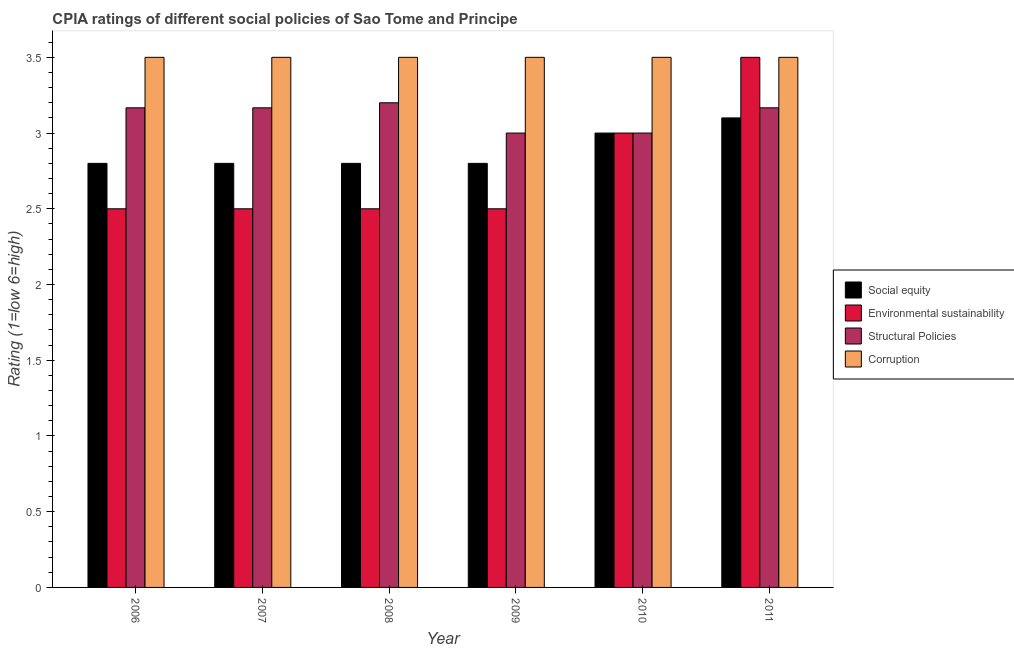How many different coloured bars are there?
Offer a very short reply. 4. How many groups of bars are there?
Your response must be concise. 6. Are the number of bars per tick equal to the number of legend labels?
Offer a very short reply. Yes. How many bars are there on the 3rd tick from the right?
Your answer should be compact. 4. What is the label of the 6th group of bars from the left?
Your answer should be very brief. 2011. What is the cpia rating of structural policies in 2006?
Your answer should be compact. 3.17. In which year was the cpia rating of corruption minimum?
Ensure brevity in your answer.  2006. What is the total cpia rating of environmental sustainability in the graph?
Provide a succinct answer. 16.5. What is the difference between the cpia rating of structural policies in 2010 and that in 2011?
Ensure brevity in your answer.  -0.17. What is the difference between the cpia rating of social equity in 2010 and the cpia rating of structural policies in 2007?
Keep it short and to the point. 0.2. What is the average cpia rating of social equity per year?
Your response must be concise. 2.88. In the year 2009, what is the difference between the cpia rating of corruption and cpia rating of structural policies?
Ensure brevity in your answer.  0. In how many years, is the cpia rating of social equity greater than 2.3?
Ensure brevity in your answer.  6. What is the ratio of the cpia rating of structural policies in 2006 to that in 2010?
Ensure brevity in your answer.  1.06. Is the cpia rating of environmental sustainability in 2008 less than that in 2011?
Your response must be concise. Yes. What is the difference between the highest and the second highest cpia rating of corruption?
Your response must be concise. 0. What is the difference between the highest and the lowest cpia rating of structural policies?
Give a very brief answer. 0.2. Is it the case that in every year, the sum of the cpia rating of environmental sustainability and cpia rating of social equity is greater than the sum of cpia rating of structural policies and cpia rating of corruption?
Provide a short and direct response. No. What does the 4th bar from the left in 2007 represents?
Make the answer very short. Corruption. What does the 4th bar from the right in 2007 represents?
Keep it short and to the point. Social equity. How many bars are there?
Provide a short and direct response. 24. Are all the bars in the graph horizontal?
Offer a very short reply. No. How many years are there in the graph?
Give a very brief answer. 6. What is the difference between two consecutive major ticks on the Y-axis?
Keep it short and to the point. 0.5. Does the graph contain any zero values?
Ensure brevity in your answer.  No. How are the legend labels stacked?
Offer a terse response. Vertical. What is the title of the graph?
Provide a succinct answer. CPIA ratings of different social policies of Sao Tome and Principe. Does "Italy" appear as one of the legend labels in the graph?
Give a very brief answer. No. What is the label or title of the X-axis?
Offer a very short reply. Year. What is the Rating (1=low 6=high) of Structural Policies in 2006?
Ensure brevity in your answer.  3.17. What is the Rating (1=low 6=high) of Social equity in 2007?
Make the answer very short. 2.8. What is the Rating (1=low 6=high) of Environmental sustainability in 2007?
Your response must be concise. 2.5. What is the Rating (1=low 6=high) of Structural Policies in 2007?
Keep it short and to the point. 3.17. What is the Rating (1=low 6=high) in Social equity in 2008?
Make the answer very short. 2.8. What is the Rating (1=low 6=high) of Environmental sustainability in 2008?
Offer a very short reply. 2.5. What is the Rating (1=low 6=high) in Corruption in 2008?
Keep it short and to the point. 3.5. What is the Rating (1=low 6=high) in Social equity in 2009?
Offer a very short reply. 2.8. What is the Rating (1=low 6=high) in Social equity in 2010?
Offer a very short reply. 3. What is the Rating (1=low 6=high) in Environmental sustainability in 2010?
Ensure brevity in your answer.  3. What is the Rating (1=low 6=high) of Structural Policies in 2010?
Give a very brief answer. 3. What is the Rating (1=low 6=high) in Corruption in 2010?
Provide a succinct answer. 3.5. What is the Rating (1=low 6=high) of Structural Policies in 2011?
Offer a terse response. 3.17. Across all years, what is the maximum Rating (1=low 6=high) in Social equity?
Your response must be concise. 3.1. Across all years, what is the maximum Rating (1=low 6=high) in Environmental sustainability?
Give a very brief answer. 3.5. Across all years, what is the maximum Rating (1=low 6=high) in Structural Policies?
Your response must be concise. 3.2. Across all years, what is the minimum Rating (1=low 6=high) in Social equity?
Your answer should be very brief. 2.8. What is the total Rating (1=low 6=high) of Environmental sustainability in the graph?
Give a very brief answer. 16.5. What is the total Rating (1=low 6=high) of Structural Policies in the graph?
Your answer should be very brief. 18.7. What is the difference between the Rating (1=low 6=high) in Environmental sustainability in 2006 and that in 2007?
Keep it short and to the point. 0. What is the difference between the Rating (1=low 6=high) in Structural Policies in 2006 and that in 2007?
Your answer should be very brief. 0. What is the difference between the Rating (1=low 6=high) of Corruption in 2006 and that in 2007?
Your answer should be very brief. 0. What is the difference between the Rating (1=low 6=high) in Social equity in 2006 and that in 2008?
Your answer should be very brief. 0. What is the difference between the Rating (1=low 6=high) in Environmental sustainability in 2006 and that in 2008?
Your answer should be compact. 0. What is the difference between the Rating (1=low 6=high) in Structural Policies in 2006 and that in 2008?
Your answer should be compact. -0.03. What is the difference between the Rating (1=low 6=high) in Environmental sustainability in 2006 and that in 2009?
Your answer should be very brief. 0. What is the difference between the Rating (1=low 6=high) of Structural Policies in 2006 and that in 2009?
Offer a very short reply. 0.17. What is the difference between the Rating (1=low 6=high) of Corruption in 2006 and that in 2009?
Provide a succinct answer. 0. What is the difference between the Rating (1=low 6=high) in Corruption in 2006 and that in 2010?
Provide a succinct answer. 0. What is the difference between the Rating (1=low 6=high) of Environmental sustainability in 2006 and that in 2011?
Give a very brief answer. -1. What is the difference between the Rating (1=low 6=high) of Corruption in 2006 and that in 2011?
Give a very brief answer. 0. What is the difference between the Rating (1=low 6=high) of Environmental sustainability in 2007 and that in 2008?
Ensure brevity in your answer.  0. What is the difference between the Rating (1=low 6=high) in Structural Policies in 2007 and that in 2008?
Give a very brief answer. -0.03. What is the difference between the Rating (1=low 6=high) in Environmental sustainability in 2007 and that in 2009?
Keep it short and to the point. 0. What is the difference between the Rating (1=low 6=high) in Structural Policies in 2007 and that in 2009?
Keep it short and to the point. 0.17. What is the difference between the Rating (1=low 6=high) of Corruption in 2007 and that in 2009?
Make the answer very short. 0. What is the difference between the Rating (1=low 6=high) of Corruption in 2007 and that in 2010?
Give a very brief answer. 0. What is the difference between the Rating (1=low 6=high) of Structural Policies in 2007 and that in 2011?
Make the answer very short. 0. What is the difference between the Rating (1=low 6=high) of Corruption in 2007 and that in 2011?
Provide a short and direct response. 0. What is the difference between the Rating (1=low 6=high) in Social equity in 2008 and that in 2009?
Offer a very short reply. 0. What is the difference between the Rating (1=low 6=high) of Structural Policies in 2008 and that in 2009?
Provide a succinct answer. 0.2. What is the difference between the Rating (1=low 6=high) of Social equity in 2008 and that in 2010?
Give a very brief answer. -0.2. What is the difference between the Rating (1=low 6=high) in Environmental sustainability in 2008 and that in 2010?
Keep it short and to the point. -0.5. What is the difference between the Rating (1=low 6=high) in Structural Policies in 2008 and that in 2010?
Your answer should be very brief. 0.2. What is the difference between the Rating (1=low 6=high) in Corruption in 2008 and that in 2010?
Make the answer very short. 0. What is the difference between the Rating (1=low 6=high) of Social equity in 2008 and that in 2011?
Offer a very short reply. -0.3. What is the difference between the Rating (1=low 6=high) of Structural Policies in 2008 and that in 2011?
Your answer should be very brief. 0.03. What is the difference between the Rating (1=low 6=high) of Environmental sustainability in 2009 and that in 2010?
Your answer should be very brief. -0.5. What is the difference between the Rating (1=low 6=high) of Structural Policies in 2009 and that in 2010?
Offer a very short reply. 0. What is the difference between the Rating (1=low 6=high) of Structural Policies in 2009 and that in 2011?
Make the answer very short. -0.17. What is the difference between the Rating (1=low 6=high) in Corruption in 2009 and that in 2011?
Keep it short and to the point. 0. What is the difference between the Rating (1=low 6=high) in Social equity in 2010 and that in 2011?
Offer a terse response. -0.1. What is the difference between the Rating (1=low 6=high) of Social equity in 2006 and the Rating (1=low 6=high) of Structural Policies in 2007?
Ensure brevity in your answer.  -0.37. What is the difference between the Rating (1=low 6=high) in Environmental sustainability in 2006 and the Rating (1=low 6=high) in Structural Policies in 2007?
Give a very brief answer. -0.67. What is the difference between the Rating (1=low 6=high) in Environmental sustainability in 2006 and the Rating (1=low 6=high) in Corruption in 2007?
Offer a terse response. -1. What is the difference between the Rating (1=low 6=high) of Structural Policies in 2006 and the Rating (1=low 6=high) of Corruption in 2007?
Keep it short and to the point. -0.33. What is the difference between the Rating (1=low 6=high) of Social equity in 2006 and the Rating (1=low 6=high) of Structural Policies in 2008?
Give a very brief answer. -0.4. What is the difference between the Rating (1=low 6=high) of Environmental sustainability in 2006 and the Rating (1=low 6=high) of Structural Policies in 2008?
Offer a very short reply. -0.7. What is the difference between the Rating (1=low 6=high) of Social equity in 2006 and the Rating (1=low 6=high) of Environmental sustainability in 2009?
Offer a very short reply. 0.3. What is the difference between the Rating (1=low 6=high) of Social equity in 2006 and the Rating (1=low 6=high) of Corruption in 2009?
Your answer should be very brief. -0.7. What is the difference between the Rating (1=low 6=high) in Environmental sustainability in 2006 and the Rating (1=low 6=high) in Corruption in 2009?
Provide a succinct answer. -1. What is the difference between the Rating (1=low 6=high) of Structural Policies in 2006 and the Rating (1=low 6=high) of Corruption in 2009?
Keep it short and to the point. -0.33. What is the difference between the Rating (1=low 6=high) of Social equity in 2006 and the Rating (1=low 6=high) of Environmental sustainability in 2010?
Give a very brief answer. -0.2. What is the difference between the Rating (1=low 6=high) in Social equity in 2006 and the Rating (1=low 6=high) in Structural Policies in 2010?
Your answer should be very brief. -0.2. What is the difference between the Rating (1=low 6=high) in Environmental sustainability in 2006 and the Rating (1=low 6=high) in Structural Policies in 2010?
Make the answer very short. -0.5. What is the difference between the Rating (1=low 6=high) in Environmental sustainability in 2006 and the Rating (1=low 6=high) in Corruption in 2010?
Keep it short and to the point. -1. What is the difference between the Rating (1=low 6=high) in Structural Policies in 2006 and the Rating (1=low 6=high) in Corruption in 2010?
Make the answer very short. -0.33. What is the difference between the Rating (1=low 6=high) of Social equity in 2006 and the Rating (1=low 6=high) of Structural Policies in 2011?
Ensure brevity in your answer.  -0.37. What is the difference between the Rating (1=low 6=high) of Environmental sustainability in 2006 and the Rating (1=low 6=high) of Structural Policies in 2011?
Make the answer very short. -0.67. What is the difference between the Rating (1=low 6=high) of Environmental sustainability in 2006 and the Rating (1=low 6=high) of Corruption in 2011?
Provide a succinct answer. -1. What is the difference between the Rating (1=low 6=high) of Social equity in 2007 and the Rating (1=low 6=high) of Structural Policies in 2008?
Provide a succinct answer. -0.4. What is the difference between the Rating (1=low 6=high) in Environmental sustainability in 2007 and the Rating (1=low 6=high) in Structural Policies in 2008?
Make the answer very short. -0.7. What is the difference between the Rating (1=low 6=high) of Environmental sustainability in 2007 and the Rating (1=low 6=high) of Corruption in 2008?
Give a very brief answer. -1. What is the difference between the Rating (1=low 6=high) in Structural Policies in 2007 and the Rating (1=low 6=high) in Corruption in 2008?
Offer a terse response. -0.33. What is the difference between the Rating (1=low 6=high) in Social equity in 2007 and the Rating (1=low 6=high) in Environmental sustainability in 2009?
Your answer should be very brief. 0.3. What is the difference between the Rating (1=low 6=high) of Social equity in 2007 and the Rating (1=low 6=high) of Structural Policies in 2009?
Give a very brief answer. -0.2. What is the difference between the Rating (1=low 6=high) in Social equity in 2007 and the Rating (1=low 6=high) in Corruption in 2009?
Make the answer very short. -0.7. What is the difference between the Rating (1=low 6=high) of Environmental sustainability in 2007 and the Rating (1=low 6=high) of Structural Policies in 2009?
Make the answer very short. -0.5. What is the difference between the Rating (1=low 6=high) in Environmental sustainability in 2007 and the Rating (1=low 6=high) in Corruption in 2009?
Provide a succinct answer. -1. What is the difference between the Rating (1=low 6=high) in Social equity in 2007 and the Rating (1=low 6=high) in Environmental sustainability in 2010?
Give a very brief answer. -0.2. What is the difference between the Rating (1=low 6=high) in Social equity in 2007 and the Rating (1=low 6=high) in Structural Policies in 2010?
Your answer should be very brief. -0.2. What is the difference between the Rating (1=low 6=high) of Social equity in 2007 and the Rating (1=low 6=high) of Environmental sustainability in 2011?
Provide a succinct answer. -0.7. What is the difference between the Rating (1=low 6=high) in Social equity in 2007 and the Rating (1=low 6=high) in Structural Policies in 2011?
Ensure brevity in your answer.  -0.37. What is the difference between the Rating (1=low 6=high) in Environmental sustainability in 2007 and the Rating (1=low 6=high) in Corruption in 2011?
Make the answer very short. -1. What is the difference between the Rating (1=low 6=high) of Environmental sustainability in 2008 and the Rating (1=low 6=high) of Corruption in 2009?
Offer a very short reply. -1. What is the difference between the Rating (1=low 6=high) in Structural Policies in 2008 and the Rating (1=low 6=high) in Corruption in 2009?
Keep it short and to the point. -0.3. What is the difference between the Rating (1=low 6=high) of Social equity in 2008 and the Rating (1=low 6=high) of Environmental sustainability in 2010?
Offer a very short reply. -0.2. What is the difference between the Rating (1=low 6=high) of Social equity in 2008 and the Rating (1=low 6=high) of Corruption in 2010?
Provide a short and direct response. -0.7. What is the difference between the Rating (1=low 6=high) in Environmental sustainability in 2008 and the Rating (1=low 6=high) in Structural Policies in 2010?
Offer a very short reply. -0.5. What is the difference between the Rating (1=low 6=high) of Environmental sustainability in 2008 and the Rating (1=low 6=high) of Corruption in 2010?
Ensure brevity in your answer.  -1. What is the difference between the Rating (1=low 6=high) in Social equity in 2008 and the Rating (1=low 6=high) in Structural Policies in 2011?
Give a very brief answer. -0.37. What is the difference between the Rating (1=low 6=high) of Social equity in 2008 and the Rating (1=low 6=high) of Corruption in 2011?
Your response must be concise. -0.7. What is the difference between the Rating (1=low 6=high) of Environmental sustainability in 2008 and the Rating (1=low 6=high) of Structural Policies in 2011?
Your response must be concise. -0.67. What is the difference between the Rating (1=low 6=high) in Environmental sustainability in 2008 and the Rating (1=low 6=high) in Corruption in 2011?
Your response must be concise. -1. What is the difference between the Rating (1=low 6=high) of Structural Policies in 2008 and the Rating (1=low 6=high) of Corruption in 2011?
Your answer should be very brief. -0.3. What is the difference between the Rating (1=low 6=high) of Social equity in 2009 and the Rating (1=low 6=high) of Environmental sustainability in 2010?
Keep it short and to the point. -0.2. What is the difference between the Rating (1=low 6=high) of Social equity in 2009 and the Rating (1=low 6=high) of Structural Policies in 2010?
Make the answer very short. -0.2. What is the difference between the Rating (1=low 6=high) in Social equity in 2009 and the Rating (1=low 6=high) in Corruption in 2010?
Provide a succinct answer. -0.7. What is the difference between the Rating (1=low 6=high) of Environmental sustainability in 2009 and the Rating (1=low 6=high) of Structural Policies in 2010?
Your response must be concise. -0.5. What is the difference between the Rating (1=low 6=high) in Social equity in 2009 and the Rating (1=low 6=high) in Environmental sustainability in 2011?
Your answer should be very brief. -0.7. What is the difference between the Rating (1=low 6=high) in Social equity in 2009 and the Rating (1=low 6=high) in Structural Policies in 2011?
Your answer should be compact. -0.37. What is the difference between the Rating (1=low 6=high) in Social equity in 2009 and the Rating (1=low 6=high) in Corruption in 2011?
Provide a short and direct response. -0.7. What is the difference between the Rating (1=low 6=high) of Environmental sustainability in 2009 and the Rating (1=low 6=high) of Structural Policies in 2011?
Offer a very short reply. -0.67. What is the difference between the Rating (1=low 6=high) in Environmental sustainability in 2009 and the Rating (1=low 6=high) in Corruption in 2011?
Offer a very short reply. -1. What is the difference between the Rating (1=low 6=high) of Social equity in 2010 and the Rating (1=low 6=high) of Environmental sustainability in 2011?
Your answer should be very brief. -0.5. What is the difference between the Rating (1=low 6=high) in Social equity in 2010 and the Rating (1=low 6=high) in Structural Policies in 2011?
Ensure brevity in your answer.  -0.17. What is the difference between the Rating (1=low 6=high) in Social equity in 2010 and the Rating (1=low 6=high) in Corruption in 2011?
Your answer should be very brief. -0.5. What is the difference between the Rating (1=low 6=high) of Environmental sustainability in 2010 and the Rating (1=low 6=high) of Structural Policies in 2011?
Your answer should be very brief. -0.17. What is the difference between the Rating (1=low 6=high) in Structural Policies in 2010 and the Rating (1=low 6=high) in Corruption in 2011?
Keep it short and to the point. -0.5. What is the average Rating (1=low 6=high) of Social equity per year?
Ensure brevity in your answer.  2.88. What is the average Rating (1=low 6=high) of Environmental sustainability per year?
Offer a terse response. 2.75. What is the average Rating (1=low 6=high) in Structural Policies per year?
Provide a succinct answer. 3.12. In the year 2006, what is the difference between the Rating (1=low 6=high) of Social equity and Rating (1=low 6=high) of Environmental sustainability?
Your answer should be very brief. 0.3. In the year 2006, what is the difference between the Rating (1=low 6=high) of Social equity and Rating (1=low 6=high) of Structural Policies?
Ensure brevity in your answer.  -0.37. In the year 2006, what is the difference between the Rating (1=low 6=high) of Environmental sustainability and Rating (1=low 6=high) of Structural Policies?
Offer a terse response. -0.67. In the year 2006, what is the difference between the Rating (1=low 6=high) of Structural Policies and Rating (1=low 6=high) of Corruption?
Give a very brief answer. -0.33. In the year 2007, what is the difference between the Rating (1=low 6=high) in Social equity and Rating (1=low 6=high) in Structural Policies?
Provide a short and direct response. -0.37. In the year 2007, what is the difference between the Rating (1=low 6=high) of Social equity and Rating (1=low 6=high) of Corruption?
Provide a short and direct response. -0.7. In the year 2007, what is the difference between the Rating (1=low 6=high) in Environmental sustainability and Rating (1=low 6=high) in Structural Policies?
Keep it short and to the point. -0.67. In the year 2007, what is the difference between the Rating (1=low 6=high) of Environmental sustainability and Rating (1=low 6=high) of Corruption?
Provide a short and direct response. -1. In the year 2008, what is the difference between the Rating (1=low 6=high) of Social equity and Rating (1=low 6=high) of Environmental sustainability?
Give a very brief answer. 0.3. In the year 2008, what is the difference between the Rating (1=low 6=high) of Structural Policies and Rating (1=low 6=high) of Corruption?
Give a very brief answer. -0.3. In the year 2009, what is the difference between the Rating (1=low 6=high) in Social equity and Rating (1=low 6=high) in Environmental sustainability?
Keep it short and to the point. 0.3. In the year 2009, what is the difference between the Rating (1=low 6=high) in Social equity and Rating (1=low 6=high) in Corruption?
Give a very brief answer. -0.7. In the year 2009, what is the difference between the Rating (1=low 6=high) of Environmental sustainability and Rating (1=low 6=high) of Structural Policies?
Your response must be concise. -0.5. In the year 2009, what is the difference between the Rating (1=low 6=high) in Environmental sustainability and Rating (1=low 6=high) in Corruption?
Your response must be concise. -1. In the year 2009, what is the difference between the Rating (1=low 6=high) of Structural Policies and Rating (1=low 6=high) of Corruption?
Give a very brief answer. -0.5. In the year 2010, what is the difference between the Rating (1=low 6=high) of Social equity and Rating (1=low 6=high) of Environmental sustainability?
Offer a terse response. 0. In the year 2010, what is the difference between the Rating (1=low 6=high) of Social equity and Rating (1=low 6=high) of Corruption?
Provide a short and direct response. -0.5. In the year 2011, what is the difference between the Rating (1=low 6=high) in Social equity and Rating (1=low 6=high) in Environmental sustainability?
Make the answer very short. -0.4. In the year 2011, what is the difference between the Rating (1=low 6=high) of Social equity and Rating (1=low 6=high) of Structural Policies?
Offer a very short reply. -0.07. What is the ratio of the Rating (1=low 6=high) of Environmental sustainability in 2006 to that in 2007?
Offer a very short reply. 1. What is the ratio of the Rating (1=low 6=high) of Structural Policies in 2006 to that in 2007?
Your response must be concise. 1. What is the ratio of the Rating (1=low 6=high) of Social equity in 2006 to that in 2008?
Offer a terse response. 1. What is the ratio of the Rating (1=low 6=high) in Structural Policies in 2006 to that in 2008?
Offer a very short reply. 0.99. What is the ratio of the Rating (1=low 6=high) of Environmental sustainability in 2006 to that in 2009?
Provide a succinct answer. 1. What is the ratio of the Rating (1=low 6=high) of Structural Policies in 2006 to that in 2009?
Provide a succinct answer. 1.06. What is the ratio of the Rating (1=low 6=high) of Environmental sustainability in 2006 to that in 2010?
Make the answer very short. 0.83. What is the ratio of the Rating (1=low 6=high) in Structural Policies in 2006 to that in 2010?
Offer a very short reply. 1.06. What is the ratio of the Rating (1=low 6=high) in Social equity in 2006 to that in 2011?
Keep it short and to the point. 0.9. What is the ratio of the Rating (1=low 6=high) in Environmental sustainability in 2006 to that in 2011?
Your answer should be very brief. 0.71. What is the ratio of the Rating (1=low 6=high) in Social equity in 2007 to that in 2008?
Your answer should be compact. 1. What is the ratio of the Rating (1=low 6=high) in Corruption in 2007 to that in 2008?
Offer a very short reply. 1. What is the ratio of the Rating (1=low 6=high) of Social equity in 2007 to that in 2009?
Make the answer very short. 1. What is the ratio of the Rating (1=low 6=high) in Structural Policies in 2007 to that in 2009?
Your answer should be very brief. 1.06. What is the ratio of the Rating (1=low 6=high) in Social equity in 2007 to that in 2010?
Offer a terse response. 0.93. What is the ratio of the Rating (1=low 6=high) in Environmental sustainability in 2007 to that in 2010?
Your answer should be very brief. 0.83. What is the ratio of the Rating (1=low 6=high) of Structural Policies in 2007 to that in 2010?
Give a very brief answer. 1.06. What is the ratio of the Rating (1=low 6=high) of Corruption in 2007 to that in 2010?
Your answer should be very brief. 1. What is the ratio of the Rating (1=low 6=high) of Social equity in 2007 to that in 2011?
Give a very brief answer. 0.9. What is the ratio of the Rating (1=low 6=high) of Structural Policies in 2007 to that in 2011?
Provide a short and direct response. 1. What is the ratio of the Rating (1=low 6=high) in Corruption in 2007 to that in 2011?
Your response must be concise. 1. What is the ratio of the Rating (1=low 6=high) of Environmental sustainability in 2008 to that in 2009?
Give a very brief answer. 1. What is the ratio of the Rating (1=low 6=high) in Structural Policies in 2008 to that in 2009?
Your answer should be very brief. 1.07. What is the ratio of the Rating (1=low 6=high) in Social equity in 2008 to that in 2010?
Provide a short and direct response. 0.93. What is the ratio of the Rating (1=low 6=high) in Environmental sustainability in 2008 to that in 2010?
Offer a terse response. 0.83. What is the ratio of the Rating (1=low 6=high) in Structural Policies in 2008 to that in 2010?
Give a very brief answer. 1.07. What is the ratio of the Rating (1=low 6=high) of Social equity in 2008 to that in 2011?
Make the answer very short. 0.9. What is the ratio of the Rating (1=low 6=high) of Structural Policies in 2008 to that in 2011?
Give a very brief answer. 1.01. What is the ratio of the Rating (1=low 6=high) in Corruption in 2009 to that in 2010?
Make the answer very short. 1. What is the ratio of the Rating (1=low 6=high) in Social equity in 2009 to that in 2011?
Your response must be concise. 0.9. What is the ratio of the Rating (1=low 6=high) of Environmental sustainability in 2009 to that in 2011?
Ensure brevity in your answer.  0.71. What is the ratio of the Rating (1=low 6=high) of Social equity in 2010 to that in 2011?
Your answer should be compact. 0.97. What is the ratio of the Rating (1=low 6=high) of Environmental sustainability in 2010 to that in 2011?
Make the answer very short. 0.86. What is the difference between the highest and the second highest Rating (1=low 6=high) of Environmental sustainability?
Your answer should be compact. 0.5. What is the difference between the highest and the second highest Rating (1=low 6=high) in Corruption?
Offer a terse response. 0. What is the difference between the highest and the lowest Rating (1=low 6=high) of Social equity?
Your answer should be compact. 0.3. What is the difference between the highest and the lowest Rating (1=low 6=high) in Environmental sustainability?
Keep it short and to the point. 1. What is the difference between the highest and the lowest Rating (1=low 6=high) in Structural Policies?
Give a very brief answer. 0.2. 